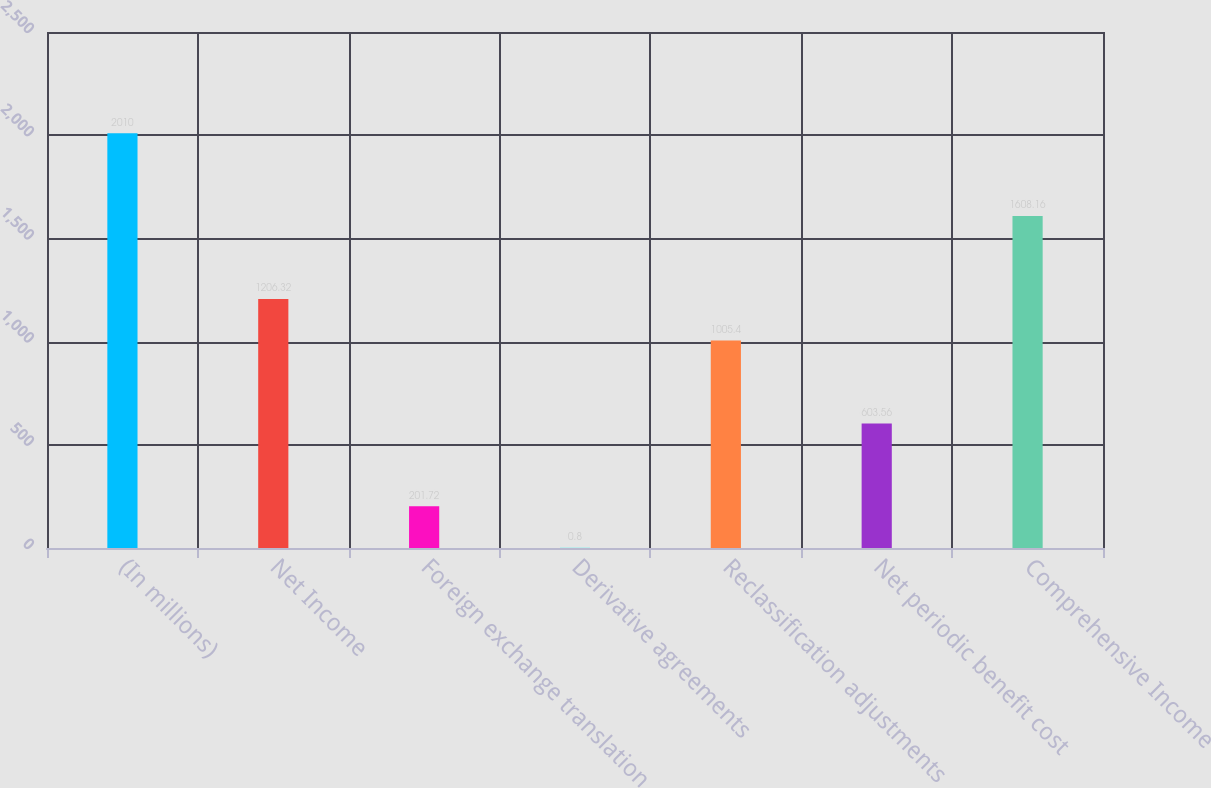Convert chart. <chart><loc_0><loc_0><loc_500><loc_500><bar_chart><fcel>(In millions)<fcel>Net Income<fcel>Foreign exchange translation<fcel>Derivative agreements<fcel>Reclassification adjustments<fcel>Net periodic benefit cost<fcel>Comprehensive Income<nl><fcel>2010<fcel>1206.32<fcel>201.72<fcel>0.8<fcel>1005.4<fcel>603.56<fcel>1608.16<nl></chart> 